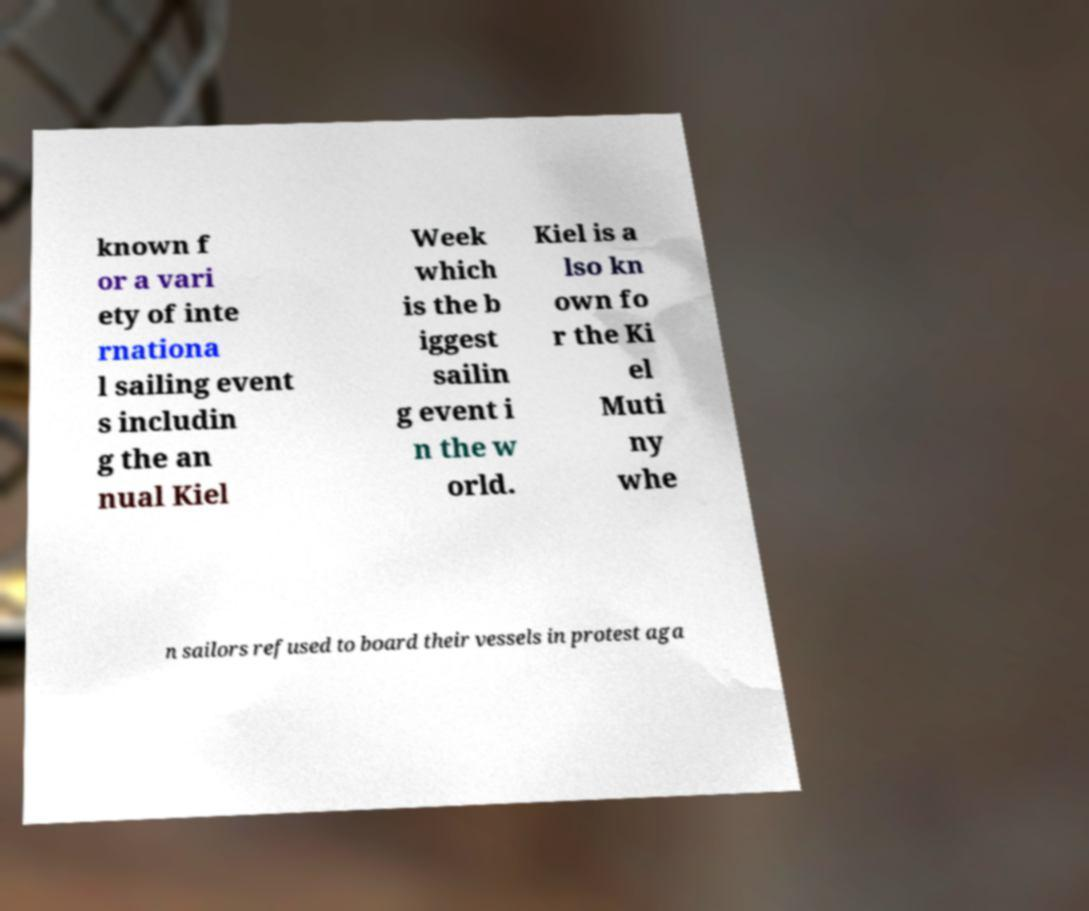For documentation purposes, I need the text within this image transcribed. Could you provide that? known f or a vari ety of inte rnationa l sailing event s includin g the an nual Kiel Week which is the b iggest sailin g event i n the w orld. Kiel is a lso kn own fo r the Ki el Muti ny whe n sailors refused to board their vessels in protest aga 